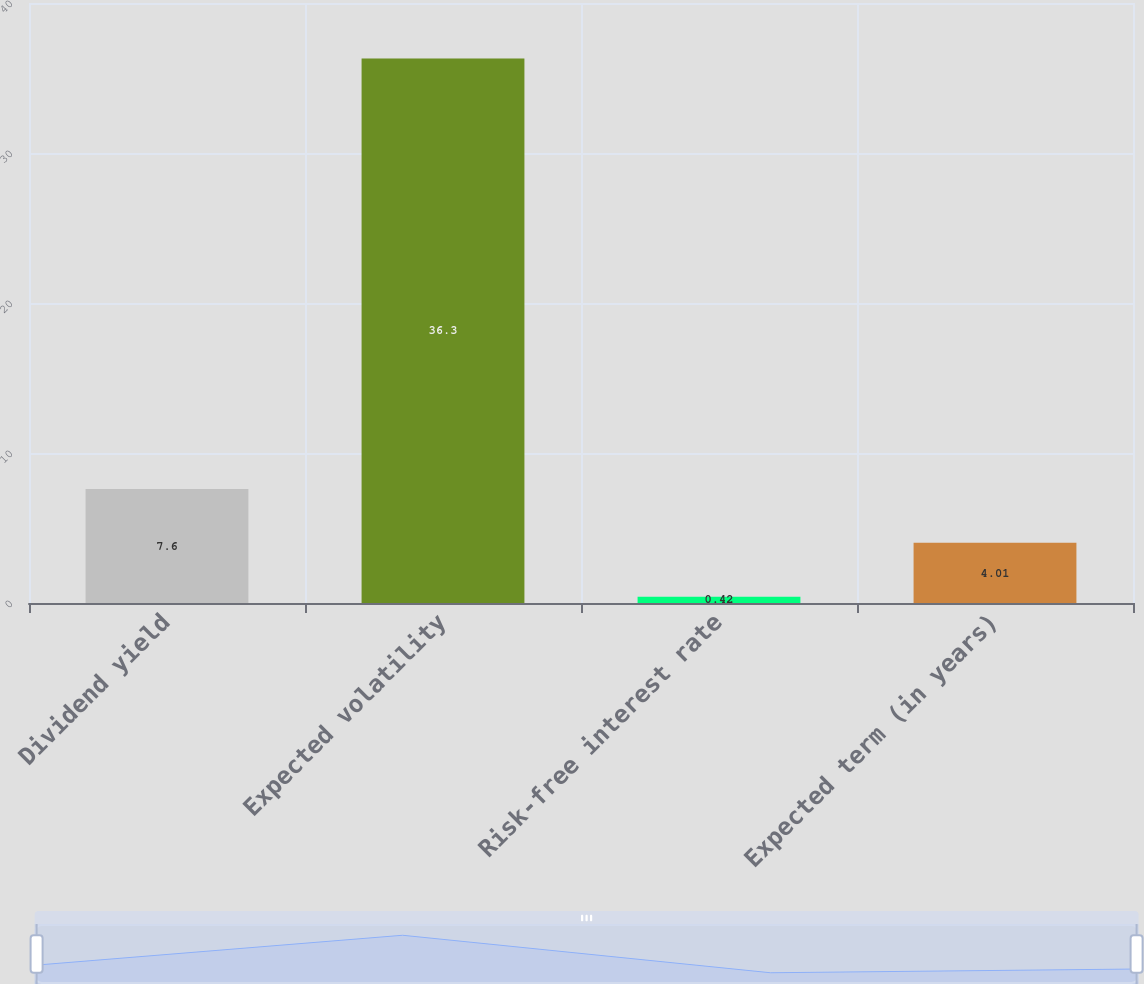<chart> <loc_0><loc_0><loc_500><loc_500><bar_chart><fcel>Dividend yield<fcel>Expected volatility<fcel>Risk-free interest rate<fcel>Expected term (in years)<nl><fcel>7.6<fcel>36.3<fcel>0.42<fcel>4.01<nl></chart> 